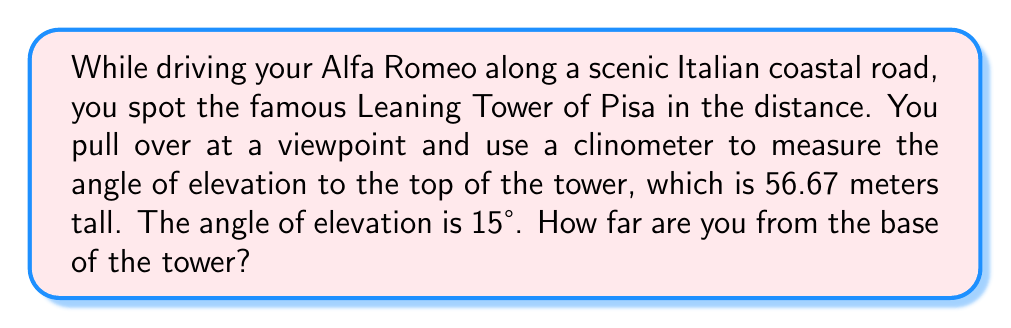Give your solution to this math problem. Let's approach this step-by-step using trigonometry:

1) First, let's visualize the problem:

[asy]
import geometry;

size(200);
pair A = (0,0), B = (300,0), C = (300,80);
draw(A--B--C--A);
label("You", A, SW);
label("Base of tower", B, SE);
label("Top of tower", C, NE);
label("56.67 m", (300,40), E);
label("x", (150,0), S);
draw(A--(0,80)--(300,80),dashed);
draw(arc(A,30,0,15),Arrow);
label("15°", (15,15), NE);
[/asy]

2) We can see that this forms a right-angled triangle. We know:
   - The opposite side (height of the tower) = 56.67 meters
   - The angle of elevation = 15°
   - We need to find the adjacent side (distance to the tower)

3) In this case, we can use the tangent function:

   $$\tan(\theta) = \frac{\text{opposite}}{\text{adjacent}}$$

4) Plugging in our known values:

   $$\tan(15°) = \frac{56.67}{\text{distance}}$$

5) To solve for the distance, we can rearrange the equation:

   $$\text{distance} = \frac{56.67}{\tan(15°)}$$

6) Now, let's calculate:
   
   $$\text{distance} = \frac{56.67}{\tan(15°)} \approx 211.45 \text{ meters}$$

Therefore, you are approximately 211.45 meters away from the base of the Leaning Tower of Pisa.
Answer: 211.45 meters 